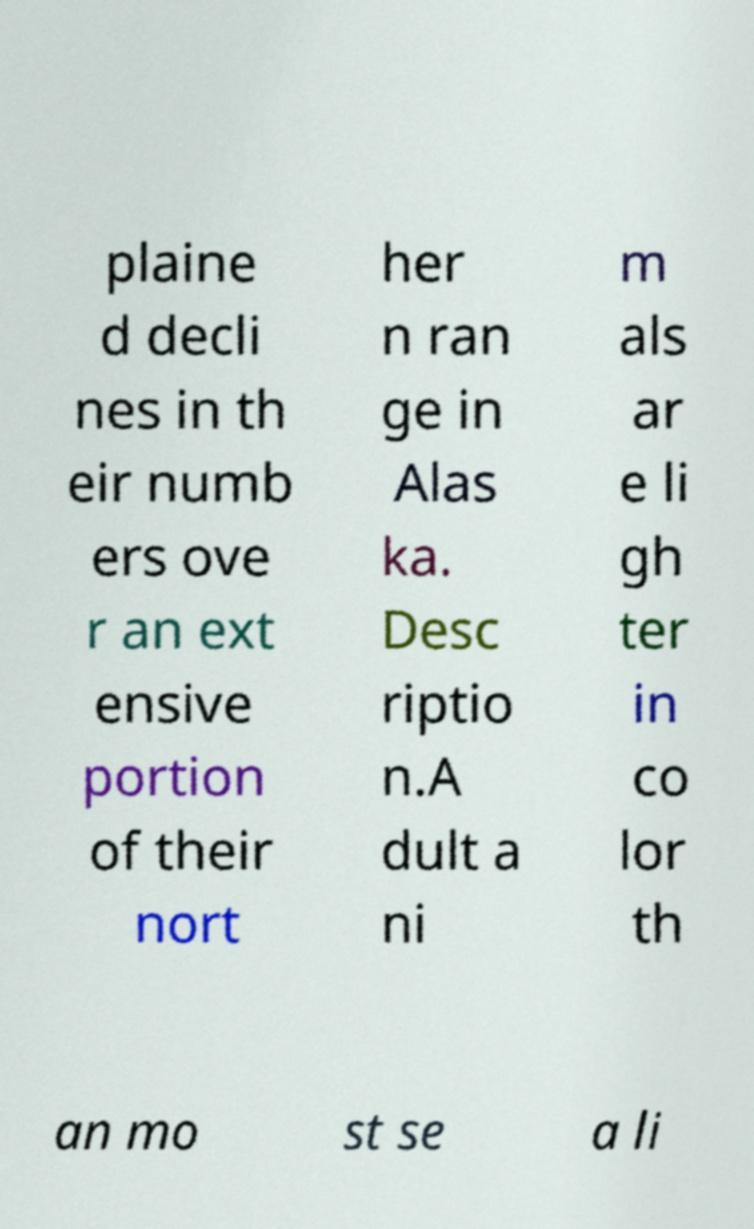Could you extract and type out the text from this image? plaine d decli nes in th eir numb ers ove r an ext ensive portion of their nort her n ran ge in Alas ka. Desc riptio n.A dult a ni m als ar e li gh ter in co lor th an mo st se a li 